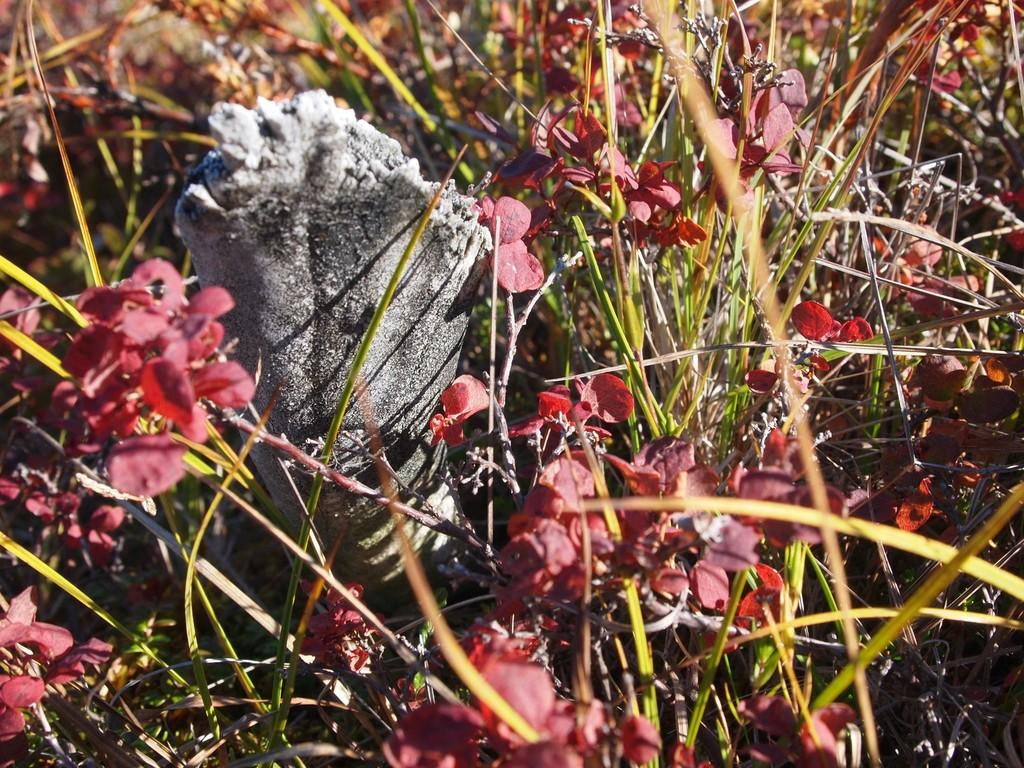What type of natural environment is visible in the image? There is grass in the image. What other living organisms can be seen in the image? There are plants in the image. Can you describe the object on the ground on the left side of the image? There is an object on the ground on the left side of the image, but its specific characteristics are not mentioned in the provided facts. What type of bun is being used to work on the plants in the image? There is no bun or any indication of work being done on the plants in the image. How many buckets of water are being used to water the grass in the image? There is no mention of buckets or watering in the image. 